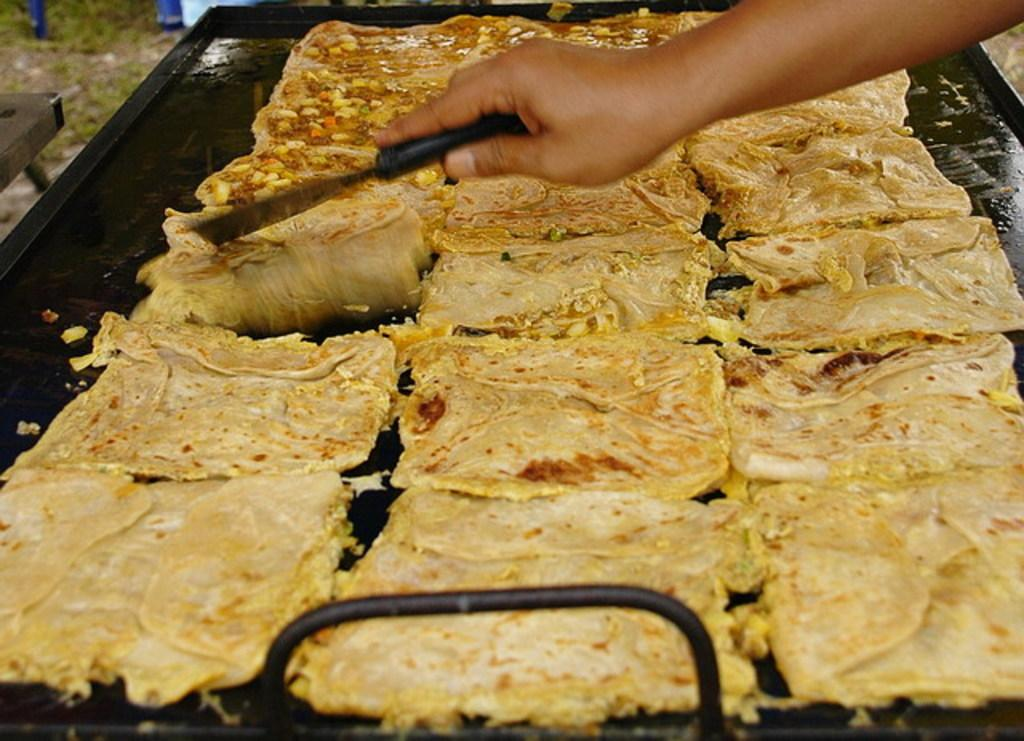What is located at the bottom of the image? There is a tray at the bottom of the image. What is on the tray? There are food items on the tray. Who is present in the image? There is a person in the image. What is the person holding? The person is holding a spatula. What might the person be doing with the spatula? The person appears to be doing something with the spatula, possibly cooking or preparing food. What type of bomb can be seen in the image? There is no bomb present in the image. Can you describe the bird that is flying in the image? There is no bird present in the image. 